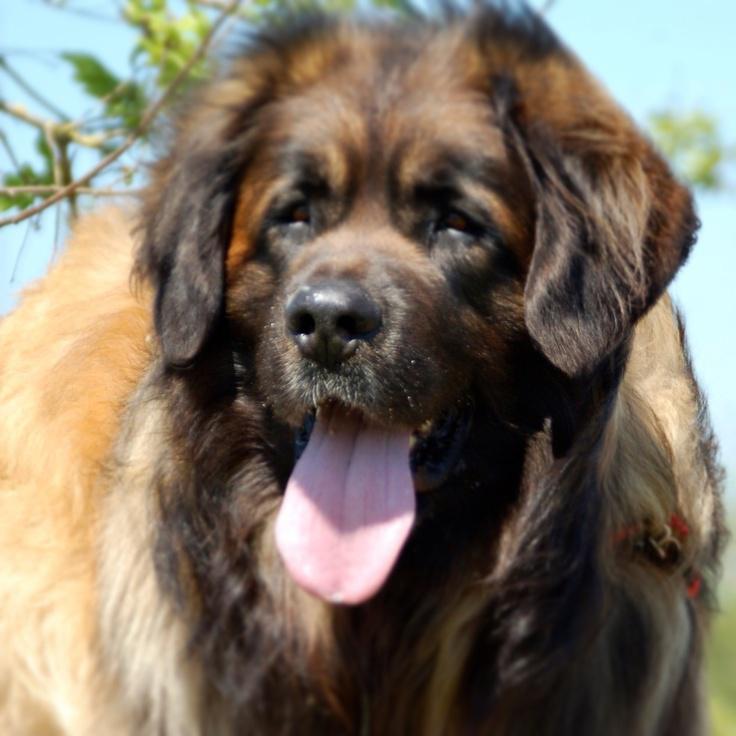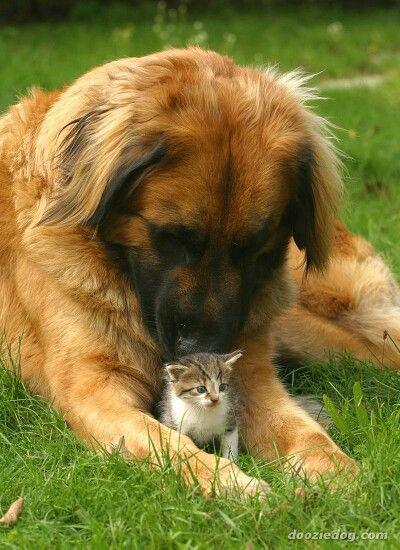The first image is the image on the left, the second image is the image on the right. Examine the images to the left and right. Is the description "The dog in the left photo has its tongue out." accurate? Answer yes or no. Yes. The first image is the image on the left, the second image is the image on the right. Evaluate the accuracy of this statement regarding the images: "An image features one dog reclining with front paws extended forward.". Is it true? Answer yes or no. Yes. 